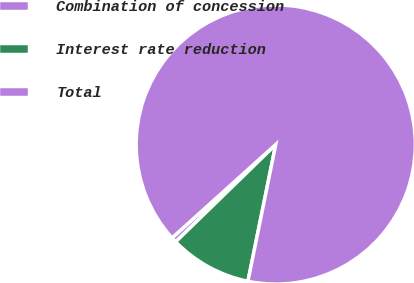Convert chart. <chart><loc_0><loc_0><loc_500><loc_500><pie_chart><fcel>Combination of concession<fcel>Interest rate reduction<fcel>Total<nl><fcel>0.61%<fcel>9.53%<fcel>89.86%<nl></chart> 